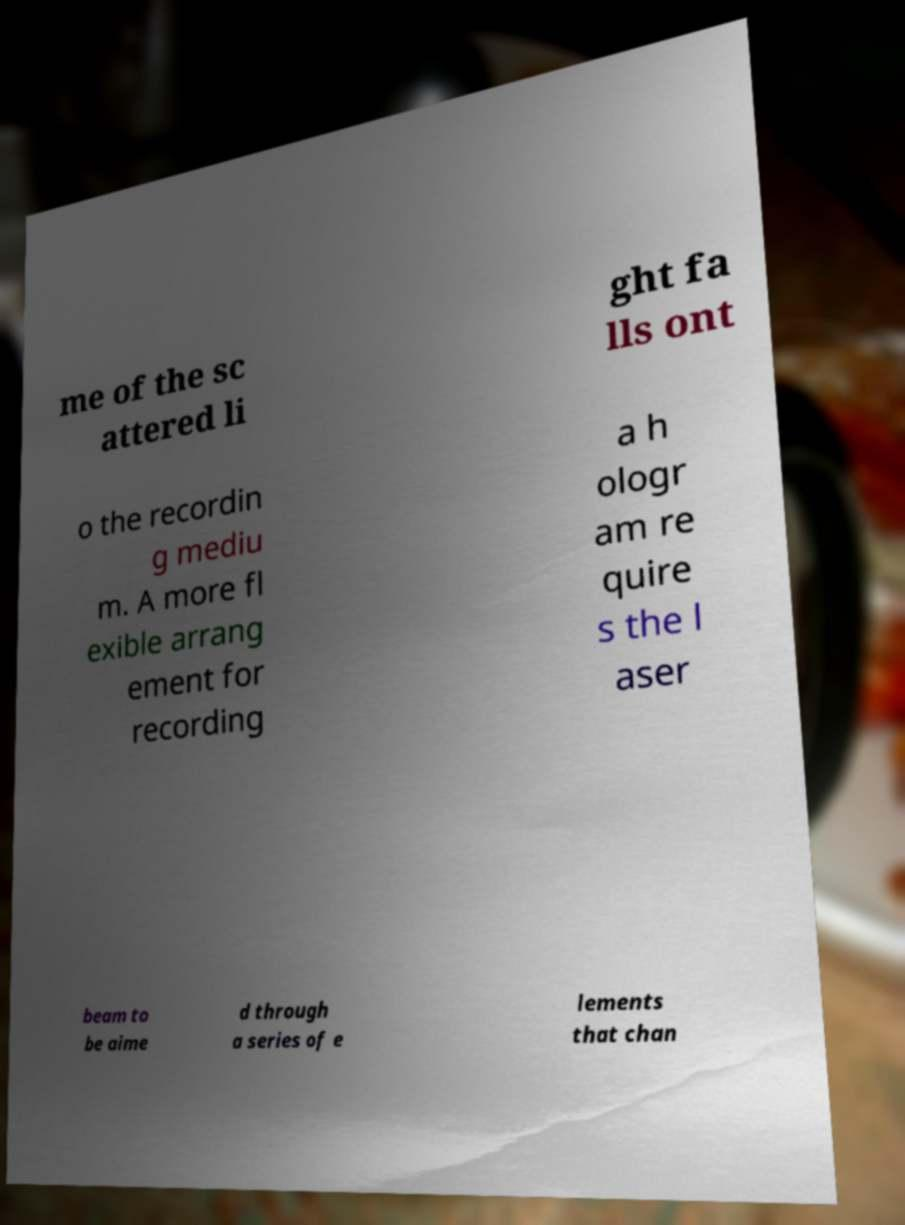Can you accurately transcribe the text from the provided image for me? me of the sc attered li ght fa lls ont o the recordin g mediu m. A more fl exible arrang ement for recording a h ologr am re quire s the l aser beam to be aime d through a series of e lements that chan 